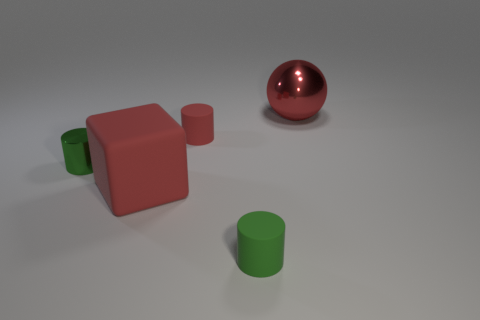Is the shape of the small green rubber thing the same as the red matte object to the right of the cube?
Your answer should be very brief. Yes. What material is the large block that is the same color as the big metallic ball?
Keep it short and to the point. Rubber. What material is the red sphere that is the same size as the block?
Ensure brevity in your answer.  Metal. Is there a rubber thing that has the same color as the matte block?
Make the answer very short. Yes. What shape is the red thing that is both in front of the metallic sphere and behind the red matte block?
Offer a very short reply. Cylinder. What number of other big red blocks have the same material as the block?
Provide a short and direct response. 0. Is the number of metallic objects on the left side of the tiny green metallic cylinder less than the number of tiny green objects behind the shiny sphere?
Make the answer very short. No. What is the green object that is behind the small cylinder in front of the big red object in front of the red shiny sphere made of?
Give a very brief answer. Metal. There is a red object that is to the right of the big block and in front of the large red ball; what size is it?
Provide a short and direct response. Small. What number of cylinders are either big objects or large matte objects?
Provide a short and direct response. 0. 